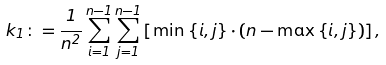<formula> <loc_0><loc_0><loc_500><loc_500>k _ { 1 } \colon = \frac { 1 } { n ^ { 2 } } \sum _ { i = 1 } ^ { n - 1 } \sum _ { j = 1 } ^ { n - 1 } \left [ \min \left \{ i , j \right \} \cdot \left ( n - \max \left \{ i , j \right \} \right ) \right ] ,</formula> 